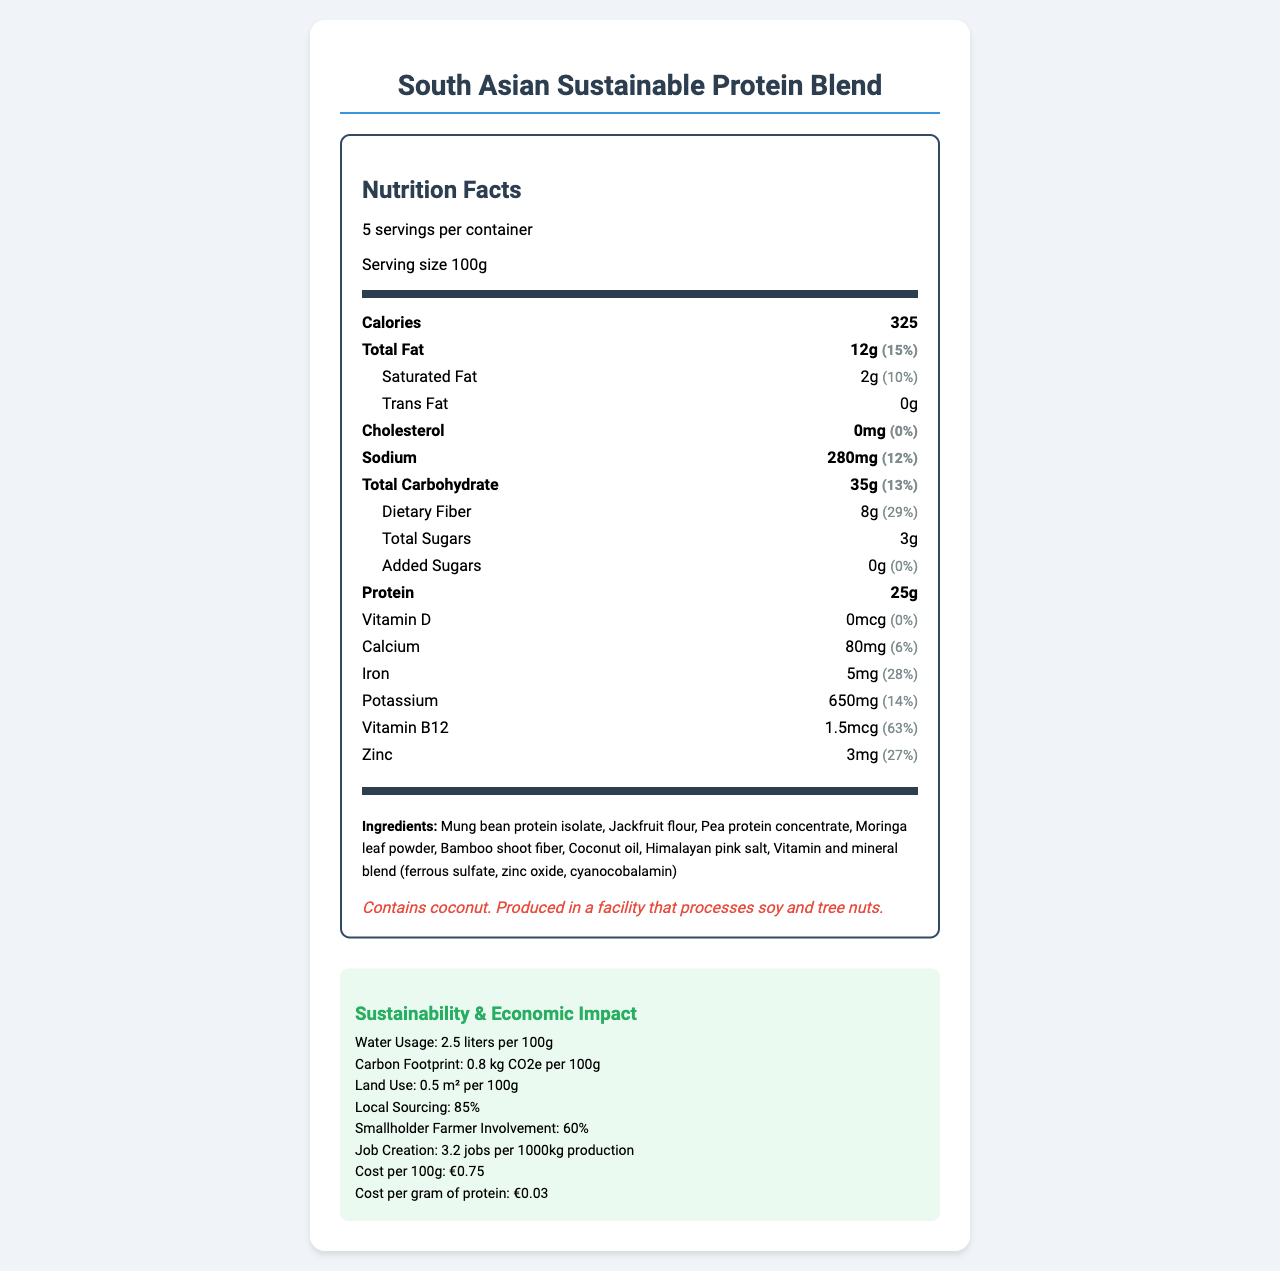what is the serving size of the South Asian Sustainable Protein Blend? The serving size is mentioned as "Serving size 100g" in the document.
Answer: 100g how many servings are in one container? The document states "5 servings per container".
Answer: 5 how many calories are in one serving? The document lists "Calories 325" for a serving size.
Answer: 325 what percentage of the daily value of iron does one serving provide? The document mentions "Iron: 5mg (28%)".
Answer: 28% how much dietary fiber is there in one serving? The document specifies "Dietary Fiber 8g (29%)".
Answer: 8g what is the primary source of protein in the blend? The ingredients list begins with "Mung bean protein isolate".
Answer: Mung bean protein isolate what is the carbon footprint per 100g of the product? The sustainability metrics state "Carbon Footprint: 0.8 kg CO2e per 100g".
Answer: 0.8 kg CO2e how much does 100g of the product cost? The cost-effectiveness section lists "price_per_100g: €0.75".
Answer: €0.75 what populations does the blend target? The document states these as target populations.
Answer: Low-income urban communities, Rural agricultural workers, Schoolchildren in government feeding programs True or False: The product contains added sugars. The document shows "Added Sugars: 0g (0%)", indicating no added sugars.
Answer: False which vitamin deficiency does the fortification strategy aim to address? A. Vitamin A B. Vitamin B12 C. Vitamin C D. Vitamin E The document mentions that the fortification strategy addresses iron, vitamin B12, and zinc deficiencies.
Answer: B what is the job creation rate per 1000kg production? A. 2.1 B. 3.2 C. 4.5 D. 5.7 The document states "Job Creation: 3.2 jobs per 1000kg production".
Answer: B how much sodium is in one serving? The document lists "Sodium: 280mg".
Answer: 280mg how would you summarize the economic impact of this product? The economic impact section details these metrics, highlighting its positive effects on the local economy.
Answer: The blend significantly involves local sourcing (85%), engages smallholder farmers (60%), and creates jobs (3.2 per 1000kg production). It potentially reduces healthcare costs, increases productivity, and reduces food imports. does the product contain allergens? The allergen information states "Contains coconut. Produced in a facility that processes soy and tree nuts."
Answer: Yes how might the product be used in cooking? The preparation methods listed suggest these uses in cooking.
Answer: Can be reconstituted with water to form a protein-rich paste, suitable for curries, stews, and as a meat substitute in traditional South Asian dishes what is the price per gram of protein in the product? The cost-effectiveness section lists "price per gram of protein: €0.03".
Answer: €0.03 how much water is used per 100g of the product? The sustainability metrics state "Water Usage: 2.5 liters per 100g".
Answer: 2.5 liters is this product free from saturated fats? The nutrition facts show "Saturated Fat: 2g (10%)".
Answer: No does the product list the vitamin A content? The document does not provide information about vitamin A content.
Answer: Not enough information 